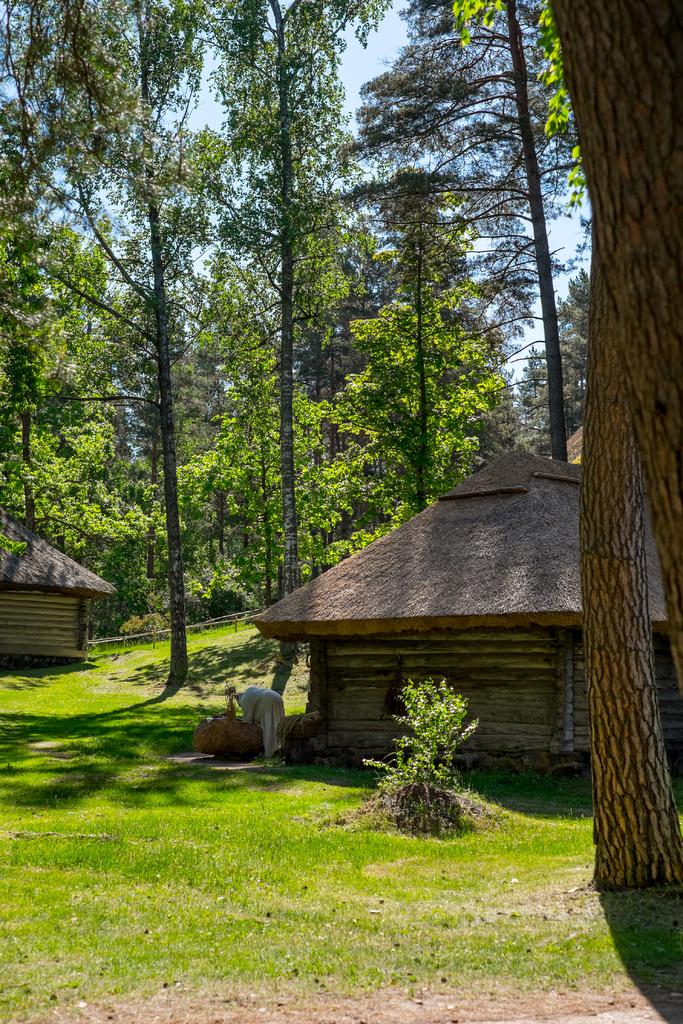What type of vegetation can be seen in the image? There are trees and plants in the image. What type of structures are present in the image? There are huts in the image. What is the ground covered with in the image? There is grass in the image. What can be seen in the background of the image? The sky is visible in the background of the image. Where is the kitten reading the book in the image? There is no kitten or book present in the image. How many tickets are visible in the image? There are no tickets visible in the image. 